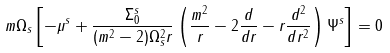Convert formula to latex. <formula><loc_0><loc_0><loc_500><loc_500>m \Omega _ { s } \left [ - \mu ^ { s } + \frac { \Sigma _ { 0 } ^ { s } } { ( m ^ { 2 } - 2 ) \Omega _ { s } ^ { 2 } r } \left ( \frac { m ^ { 2 } } { r } - 2 \frac { d } { d r } - r \frac { d ^ { 2 } } { d r ^ { 2 } } \right ) \Psi ^ { s } \right ] = 0</formula> 